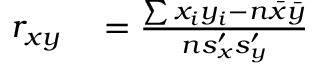<formula> <loc_0><loc_0><loc_500><loc_500>\begin{array} { r l } { r _ { x y } } & = { \frac { \sum x _ { i } y _ { i } - n { \bar { x } } { \bar { y } } } { n s _ { x } ^ { \prime } s _ { y } ^ { \prime } } } } \end{array}</formula> 